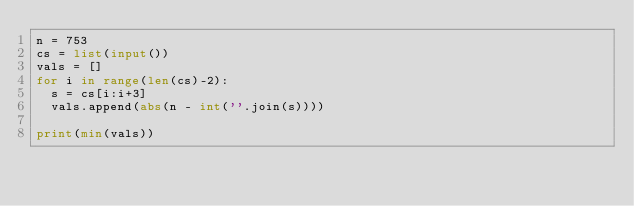<code> <loc_0><loc_0><loc_500><loc_500><_Python_>n = 753
cs = list(input())
vals = []
for i in range(len(cs)-2):
  s = cs[i:i+3]
  vals.append(abs(n - int(''.join(s))))

print(min(vals))

</code> 